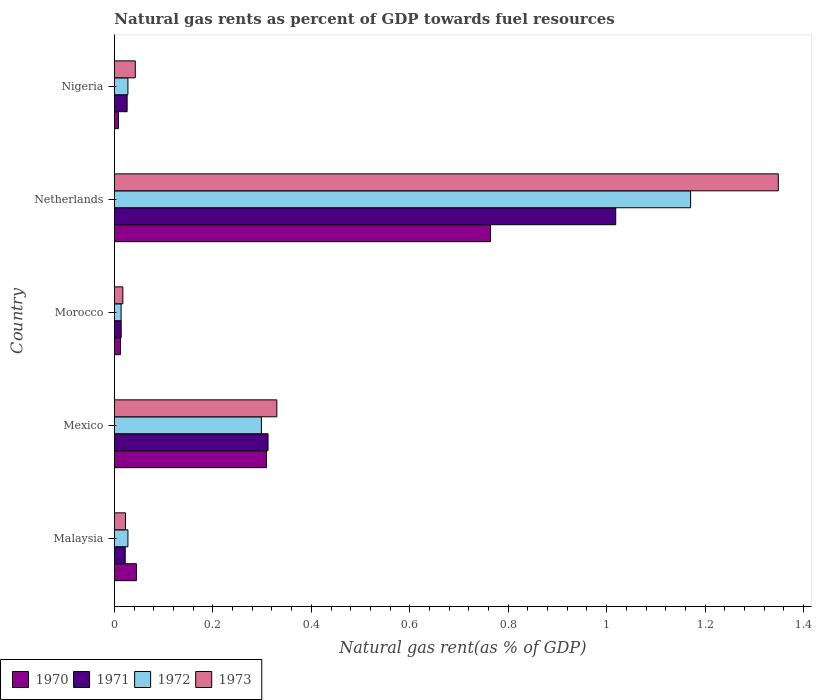How many groups of bars are there?
Your answer should be compact. 5. Are the number of bars per tick equal to the number of legend labels?
Your response must be concise. Yes. How many bars are there on the 4th tick from the top?
Your response must be concise. 4. In how many cases, is the number of bars for a given country not equal to the number of legend labels?
Ensure brevity in your answer.  0. What is the natural gas rent in 1971 in Morocco?
Ensure brevity in your answer.  0.01. Across all countries, what is the maximum natural gas rent in 1972?
Keep it short and to the point. 1.17. Across all countries, what is the minimum natural gas rent in 1973?
Your answer should be very brief. 0.02. In which country was the natural gas rent in 1970 maximum?
Provide a succinct answer. Netherlands. In which country was the natural gas rent in 1973 minimum?
Make the answer very short. Morocco. What is the total natural gas rent in 1971 in the graph?
Keep it short and to the point. 1.39. What is the difference between the natural gas rent in 1973 in Netherlands and that in Nigeria?
Provide a short and direct response. 1.31. What is the difference between the natural gas rent in 1972 in Morocco and the natural gas rent in 1973 in Malaysia?
Provide a short and direct response. -0.01. What is the average natural gas rent in 1970 per country?
Ensure brevity in your answer.  0.23. What is the difference between the natural gas rent in 1972 and natural gas rent in 1970 in Malaysia?
Keep it short and to the point. -0.02. In how many countries, is the natural gas rent in 1970 greater than 0.8400000000000001 %?
Give a very brief answer. 0. What is the ratio of the natural gas rent in 1971 in Malaysia to that in Mexico?
Provide a succinct answer. 0.07. Is the natural gas rent in 1970 in Netherlands less than that in Nigeria?
Your response must be concise. No. Is the difference between the natural gas rent in 1972 in Netherlands and Nigeria greater than the difference between the natural gas rent in 1970 in Netherlands and Nigeria?
Your answer should be compact. Yes. What is the difference between the highest and the second highest natural gas rent in 1971?
Give a very brief answer. 0.71. What is the difference between the highest and the lowest natural gas rent in 1972?
Make the answer very short. 1.16. In how many countries, is the natural gas rent in 1973 greater than the average natural gas rent in 1973 taken over all countries?
Your answer should be very brief. 1. Is the sum of the natural gas rent in 1970 in Malaysia and Netherlands greater than the maximum natural gas rent in 1971 across all countries?
Give a very brief answer. No. Is it the case that in every country, the sum of the natural gas rent in 1970 and natural gas rent in 1973 is greater than the sum of natural gas rent in 1972 and natural gas rent in 1971?
Give a very brief answer. No. What does the 4th bar from the bottom in Mexico represents?
Offer a very short reply. 1973. How many bars are there?
Your answer should be compact. 20. Are all the bars in the graph horizontal?
Offer a very short reply. Yes. What is the difference between two consecutive major ticks on the X-axis?
Provide a succinct answer. 0.2. Are the values on the major ticks of X-axis written in scientific E-notation?
Your answer should be compact. No. Does the graph contain grids?
Keep it short and to the point. No. Where does the legend appear in the graph?
Provide a short and direct response. Bottom left. How many legend labels are there?
Your answer should be very brief. 4. How are the legend labels stacked?
Provide a short and direct response. Horizontal. What is the title of the graph?
Give a very brief answer. Natural gas rents as percent of GDP towards fuel resources. What is the label or title of the X-axis?
Offer a terse response. Natural gas rent(as % of GDP). What is the label or title of the Y-axis?
Your response must be concise. Country. What is the Natural gas rent(as % of GDP) of 1970 in Malaysia?
Provide a short and direct response. 0.04. What is the Natural gas rent(as % of GDP) in 1971 in Malaysia?
Your response must be concise. 0.02. What is the Natural gas rent(as % of GDP) in 1972 in Malaysia?
Provide a succinct answer. 0.03. What is the Natural gas rent(as % of GDP) in 1973 in Malaysia?
Your answer should be compact. 0.02. What is the Natural gas rent(as % of GDP) of 1970 in Mexico?
Offer a terse response. 0.31. What is the Natural gas rent(as % of GDP) in 1971 in Mexico?
Make the answer very short. 0.31. What is the Natural gas rent(as % of GDP) of 1972 in Mexico?
Offer a terse response. 0.3. What is the Natural gas rent(as % of GDP) of 1973 in Mexico?
Ensure brevity in your answer.  0.33. What is the Natural gas rent(as % of GDP) of 1970 in Morocco?
Give a very brief answer. 0.01. What is the Natural gas rent(as % of GDP) of 1971 in Morocco?
Your answer should be very brief. 0.01. What is the Natural gas rent(as % of GDP) of 1972 in Morocco?
Your answer should be very brief. 0.01. What is the Natural gas rent(as % of GDP) of 1973 in Morocco?
Make the answer very short. 0.02. What is the Natural gas rent(as % of GDP) in 1970 in Netherlands?
Make the answer very short. 0.76. What is the Natural gas rent(as % of GDP) of 1971 in Netherlands?
Give a very brief answer. 1.02. What is the Natural gas rent(as % of GDP) of 1972 in Netherlands?
Keep it short and to the point. 1.17. What is the Natural gas rent(as % of GDP) of 1973 in Netherlands?
Provide a succinct answer. 1.35. What is the Natural gas rent(as % of GDP) of 1970 in Nigeria?
Offer a terse response. 0.01. What is the Natural gas rent(as % of GDP) of 1971 in Nigeria?
Provide a succinct answer. 0.03. What is the Natural gas rent(as % of GDP) in 1972 in Nigeria?
Your response must be concise. 0.03. What is the Natural gas rent(as % of GDP) in 1973 in Nigeria?
Your answer should be compact. 0.04. Across all countries, what is the maximum Natural gas rent(as % of GDP) of 1970?
Keep it short and to the point. 0.76. Across all countries, what is the maximum Natural gas rent(as % of GDP) in 1971?
Make the answer very short. 1.02. Across all countries, what is the maximum Natural gas rent(as % of GDP) of 1972?
Keep it short and to the point. 1.17. Across all countries, what is the maximum Natural gas rent(as % of GDP) in 1973?
Provide a succinct answer. 1.35. Across all countries, what is the minimum Natural gas rent(as % of GDP) in 1970?
Your answer should be very brief. 0.01. Across all countries, what is the minimum Natural gas rent(as % of GDP) in 1971?
Your answer should be compact. 0.01. Across all countries, what is the minimum Natural gas rent(as % of GDP) in 1972?
Your answer should be compact. 0.01. Across all countries, what is the minimum Natural gas rent(as % of GDP) of 1973?
Your response must be concise. 0.02. What is the total Natural gas rent(as % of GDP) in 1970 in the graph?
Ensure brevity in your answer.  1.14. What is the total Natural gas rent(as % of GDP) in 1971 in the graph?
Your answer should be compact. 1.39. What is the total Natural gas rent(as % of GDP) of 1972 in the graph?
Keep it short and to the point. 1.54. What is the total Natural gas rent(as % of GDP) of 1973 in the graph?
Offer a terse response. 1.76. What is the difference between the Natural gas rent(as % of GDP) in 1970 in Malaysia and that in Mexico?
Offer a very short reply. -0.26. What is the difference between the Natural gas rent(as % of GDP) of 1971 in Malaysia and that in Mexico?
Offer a terse response. -0.29. What is the difference between the Natural gas rent(as % of GDP) of 1972 in Malaysia and that in Mexico?
Keep it short and to the point. -0.27. What is the difference between the Natural gas rent(as % of GDP) in 1973 in Malaysia and that in Mexico?
Provide a short and direct response. -0.31. What is the difference between the Natural gas rent(as % of GDP) in 1970 in Malaysia and that in Morocco?
Ensure brevity in your answer.  0.03. What is the difference between the Natural gas rent(as % of GDP) in 1971 in Malaysia and that in Morocco?
Provide a short and direct response. 0.01. What is the difference between the Natural gas rent(as % of GDP) in 1972 in Malaysia and that in Morocco?
Give a very brief answer. 0.01. What is the difference between the Natural gas rent(as % of GDP) of 1973 in Malaysia and that in Morocco?
Offer a very short reply. 0.01. What is the difference between the Natural gas rent(as % of GDP) of 1970 in Malaysia and that in Netherlands?
Your answer should be very brief. -0.72. What is the difference between the Natural gas rent(as % of GDP) in 1971 in Malaysia and that in Netherlands?
Make the answer very short. -1. What is the difference between the Natural gas rent(as % of GDP) in 1972 in Malaysia and that in Netherlands?
Your response must be concise. -1.14. What is the difference between the Natural gas rent(as % of GDP) of 1973 in Malaysia and that in Netherlands?
Your answer should be compact. -1.33. What is the difference between the Natural gas rent(as % of GDP) of 1970 in Malaysia and that in Nigeria?
Keep it short and to the point. 0.04. What is the difference between the Natural gas rent(as % of GDP) in 1971 in Malaysia and that in Nigeria?
Keep it short and to the point. -0. What is the difference between the Natural gas rent(as % of GDP) in 1972 in Malaysia and that in Nigeria?
Your response must be concise. 0. What is the difference between the Natural gas rent(as % of GDP) of 1973 in Malaysia and that in Nigeria?
Your answer should be very brief. -0.02. What is the difference between the Natural gas rent(as % of GDP) in 1970 in Mexico and that in Morocco?
Your response must be concise. 0.3. What is the difference between the Natural gas rent(as % of GDP) of 1971 in Mexico and that in Morocco?
Keep it short and to the point. 0.3. What is the difference between the Natural gas rent(as % of GDP) of 1972 in Mexico and that in Morocco?
Offer a terse response. 0.28. What is the difference between the Natural gas rent(as % of GDP) of 1973 in Mexico and that in Morocco?
Offer a very short reply. 0.31. What is the difference between the Natural gas rent(as % of GDP) in 1970 in Mexico and that in Netherlands?
Provide a succinct answer. -0.46. What is the difference between the Natural gas rent(as % of GDP) of 1971 in Mexico and that in Netherlands?
Ensure brevity in your answer.  -0.71. What is the difference between the Natural gas rent(as % of GDP) of 1972 in Mexico and that in Netherlands?
Make the answer very short. -0.87. What is the difference between the Natural gas rent(as % of GDP) of 1973 in Mexico and that in Netherlands?
Offer a very short reply. -1.02. What is the difference between the Natural gas rent(as % of GDP) of 1970 in Mexico and that in Nigeria?
Keep it short and to the point. 0.3. What is the difference between the Natural gas rent(as % of GDP) of 1971 in Mexico and that in Nigeria?
Offer a terse response. 0.29. What is the difference between the Natural gas rent(as % of GDP) of 1972 in Mexico and that in Nigeria?
Offer a very short reply. 0.27. What is the difference between the Natural gas rent(as % of GDP) in 1973 in Mexico and that in Nigeria?
Your answer should be compact. 0.29. What is the difference between the Natural gas rent(as % of GDP) in 1970 in Morocco and that in Netherlands?
Give a very brief answer. -0.75. What is the difference between the Natural gas rent(as % of GDP) in 1971 in Morocco and that in Netherlands?
Offer a terse response. -1. What is the difference between the Natural gas rent(as % of GDP) of 1972 in Morocco and that in Netherlands?
Your response must be concise. -1.16. What is the difference between the Natural gas rent(as % of GDP) of 1973 in Morocco and that in Netherlands?
Give a very brief answer. -1.33. What is the difference between the Natural gas rent(as % of GDP) of 1970 in Morocco and that in Nigeria?
Keep it short and to the point. 0. What is the difference between the Natural gas rent(as % of GDP) of 1971 in Morocco and that in Nigeria?
Your answer should be very brief. -0.01. What is the difference between the Natural gas rent(as % of GDP) of 1972 in Morocco and that in Nigeria?
Keep it short and to the point. -0.01. What is the difference between the Natural gas rent(as % of GDP) in 1973 in Morocco and that in Nigeria?
Your response must be concise. -0.03. What is the difference between the Natural gas rent(as % of GDP) of 1970 in Netherlands and that in Nigeria?
Your answer should be very brief. 0.76. What is the difference between the Natural gas rent(as % of GDP) in 1972 in Netherlands and that in Nigeria?
Your answer should be very brief. 1.14. What is the difference between the Natural gas rent(as % of GDP) in 1973 in Netherlands and that in Nigeria?
Your answer should be very brief. 1.31. What is the difference between the Natural gas rent(as % of GDP) of 1970 in Malaysia and the Natural gas rent(as % of GDP) of 1971 in Mexico?
Provide a short and direct response. -0.27. What is the difference between the Natural gas rent(as % of GDP) in 1970 in Malaysia and the Natural gas rent(as % of GDP) in 1972 in Mexico?
Make the answer very short. -0.25. What is the difference between the Natural gas rent(as % of GDP) of 1970 in Malaysia and the Natural gas rent(as % of GDP) of 1973 in Mexico?
Provide a succinct answer. -0.29. What is the difference between the Natural gas rent(as % of GDP) in 1971 in Malaysia and the Natural gas rent(as % of GDP) in 1972 in Mexico?
Keep it short and to the point. -0.28. What is the difference between the Natural gas rent(as % of GDP) of 1971 in Malaysia and the Natural gas rent(as % of GDP) of 1973 in Mexico?
Provide a succinct answer. -0.31. What is the difference between the Natural gas rent(as % of GDP) in 1972 in Malaysia and the Natural gas rent(as % of GDP) in 1973 in Mexico?
Your answer should be compact. -0.3. What is the difference between the Natural gas rent(as % of GDP) in 1970 in Malaysia and the Natural gas rent(as % of GDP) in 1971 in Morocco?
Your response must be concise. 0.03. What is the difference between the Natural gas rent(as % of GDP) in 1970 in Malaysia and the Natural gas rent(as % of GDP) in 1972 in Morocco?
Your answer should be compact. 0.03. What is the difference between the Natural gas rent(as % of GDP) in 1970 in Malaysia and the Natural gas rent(as % of GDP) in 1973 in Morocco?
Offer a terse response. 0.03. What is the difference between the Natural gas rent(as % of GDP) of 1971 in Malaysia and the Natural gas rent(as % of GDP) of 1972 in Morocco?
Your response must be concise. 0.01. What is the difference between the Natural gas rent(as % of GDP) of 1971 in Malaysia and the Natural gas rent(as % of GDP) of 1973 in Morocco?
Provide a succinct answer. 0. What is the difference between the Natural gas rent(as % of GDP) of 1972 in Malaysia and the Natural gas rent(as % of GDP) of 1973 in Morocco?
Give a very brief answer. 0.01. What is the difference between the Natural gas rent(as % of GDP) of 1970 in Malaysia and the Natural gas rent(as % of GDP) of 1971 in Netherlands?
Offer a terse response. -0.97. What is the difference between the Natural gas rent(as % of GDP) of 1970 in Malaysia and the Natural gas rent(as % of GDP) of 1972 in Netherlands?
Offer a terse response. -1.13. What is the difference between the Natural gas rent(as % of GDP) of 1970 in Malaysia and the Natural gas rent(as % of GDP) of 1973 in Netherlands?
Ensure brevity in your answer.  -1.3. What is the difference between the Natural gas rent(as % of GDP) of 1971 in Malaysia and the Natural gas rent(as % of GDP) of 1972 in Netherlands?
Ensure brevity in your answer.  -1.15. What is the difference between the Natural gas rent(as % of GDP) in 1971 in Malaysia and the Natural gas rent(as % of GDP) in 1973 in Netherlands?
Your answer should be very brief. -1.33. What is the difference between the Natural gas rent(as % of GDP) in 1972 in Malaysia and the Natural gas rent(as % of GDP) in 1973 in Netherlands?
Ensure brevity in your answer.  -1.32. What is the difference between the Natural gas rent(as % of GDP) of 1970 in Malaysia and the Natural gas rent(as % of GDP) of 1971 in Nigeria?
Keep it short and to the point. 0.02. What is the difference between the Natural gas rent(as % of GDP) of 1970 in Malaysia and the Natural gas rent(as % of GDP) of 1972 in Nigeria?
Your answer should be very brief. 0.02. What is the difference between the Natural gas rent(as % of GDP) of 1970 in Malaysia and the Natural gas rent(as % of GDP) of 1973 in Nigeria?
Give a very brief answer. 0. What is the difference between the Natural gas rent(as % of GDP) in 1971 in Malaysia and the Natural gas rent(as % of GDP) in 1972 in Nigeria?
Keep it short and to the point. -0.01. What is the difference between the Natural gas rent(as % of GDP) in 1971 in Malaysia and the Natural gas rent(as % of GDP) in 1973 in Nigeria?
Your answer should be compact. -0.02. What is the difference between the Natural gas rent(as % of GDP) in 1972 in Malaysia and the Natural gas rent(as % of GDP) in 1973 in Nigeria?
Your response must be concise. -0.01. What is the difference between the Natural gas rent(as % of GDP) in 1970 in Mexico and the Natural gas rent(as % of GDP) in 1971 in Morocco?
Provide a succinct answer. 0.3. What is the difference between the Natural gas rent(as % of GDP) of 1970 in Mexico and the Natural gas rent(as % of GDP) of 1972 in Morocco?
Provide a short and direct response. 0.3. What is the difference between the Natural gas rent(as % of GDP) of 1970 in Mexico and the Natural gas rent(as % of GDP) of 1973 in Morocco?
Keep it short and to the point. 0.29. What is the difference between the Natural gas rent(as % of GDP) of 1971 in Mexico and the Natural gas rent(as % of GDP) of 1972 in Morocco?
Make the answer very short. 0.3. What is the difference between the Natural gas rent(as % of GDP) in 1971 in Mexico and the Natural gas rent(as % of GDP) in 1973 in Morocco?
Provide a succinct answer. 0.29. What is the difference between the Natural gas rent(as % of GDP) of 1972 in Mexico and the Natural gas rent(as % of GDP) of 1973 in Morocco?
Make the answer very short. 0.28. What is the difference between the Natural gas rent(as % of GDP) in 1970 in Mexico and the Natural gas rent(as % of GDP) in 1971 in Netherlands?
Your answer should be very brief. -0.71. What is the difference between the Natural gas rent(as % of GDP) of 1970 in Mexico and the Natural gas rent(as % of GDP) of 1972 in Netherlands?
Make the answer very short. -0.86. What is the difference between the Natural gas rent(as % of GDP) of 1970 in Mexico and the Natural gas rent(as % of GDP) of 1973 in Netherlands?
Make the answer very short. -1.04. What is the difference between the Natural gas rent(as % of GDP) of 1971 in Mexico and the Natural gas rent(as % of GDP) of 1972 in Netherlands?
Ensure brevity in your answer.  -0.86. What is the difference between the Natural gas rent(as % of GDP) of 1971 in Mexico and the Natural gas rent(as % of GDP) of 1973 in Netherlands?
Your answer should be compact. -1.04. What is the difference between the Natural gas rent(as % of GDP) of 1972 in Mexico and the Natural gas rent(as % of GDP) of 1973 in Netherlands?
Your answer should be very brief. -1.05. What is the difference between the Natural gas rent(as % of GDP) of 1970 in Mexico and the Natural gas rent(as % of GDP) of 1971 in Nigeria?
Your answer should be very brief. 0.28. What is the difference between the Natural gas rent(as % of GDP) of 1970 in Mexico and the Natural gas rent(as % of GDP) of 1972 in Nigeria?
Offer a very short reply. 0.28. What is the difference between the Natural gas rent(as % of GDP) in 1970 in Mexico and the Natural gas rent(as % of GDP) in 1973 in Nigeria?
Your answer should be very brief. 0.27. What is the difference between the Natural gas rent(as % of GDP) in 1971 in Mexico and the Natural gas rent(as % of GDP) in 1972 in Nigeria?
Your answer should be compact. 0.28. What is the difference between the Natural gas rent(as % of GDP) in 1971 in Mexico and the Natural gas rent(as % of GDP) in 1973 in Nigeria?
Provide a succinct answer. 0.27. What is the difference between the Natural gas rent(as % of GDP) in 1972 in Mexico and the Natural gas rent(as % of GDP) in 1973 in Nigeria?
Give a very brief answer. 0.26. What is the difference between the Natural gas rent(as % of GDP) of 1970 in Morocco and the Natural gas rent(as % of GDP) of 1971 in Netherlands?
Give a very brief answer. -1.01. What is the difference between the Natural gas rent(as % of GDP) in 1970 in Morocco and the Natural gas rent(as % of GDP) in 1972 in Netherlands?
Provide a short and direct response. -1.16. What is the difference between the Natural gas rent(as % of GDP) in 1970 in Morocco and the Natural gas rent(as % of GDP) in 1973 in Netherlands?
Offer a very short reply. -1.34. What is the difference between the Natural gas rent(as % of GDP) in 1971 in Morocco and the Natural gas rent(as % of GDP) in 1972 in Netherlands?
Keep it short and to the point. -1.16. What is the difference between the Natural gas rent(as % of GDP) of 1971 in Morocco and the Natural gas rent(as % of GDP) of 1973 in Netherlands?
Ensure brevity in your answer.  -1.33. What is the difference between the Natural gas rent(as % of GDP) of 1972 in Morocco and the Natural gas rent(as % of GDP) of 1973 in Netherlands?
Make the answer very short. -1.34. What is the difference between the Natural gas rent(as % of GDP) in 1970 in Morocco and the Natural gas rent(as % of GDP) in 1971 in Nigeria?
Give a very brief answer. -0.01. What is the difference between the Natural gas rent(as % of GDP) of 1970 in Morocco and the Natural gas rent(as % of GDP) of 1972 in Nigeria?
Your answer should be compact. -0.02. What is the difference between the Natural gas rent(as % of GDP) in 1970 in Morocco and the Natural gas rent(as % of GDP) in 1973 in Nigeria?
Provide a short and direct response. -0.03. What is the difference between the Natural gas rent(as % of GDP) in 1971 in Morocco and the Natural gas rent(as % of GDP) in 1972 in Nigeria?
Ensure brevity in your answer.  -0.01. What is the difference between the Natural gas rent(as % of GDP) in 1971 in Morocco and the Natural gas rent(as % of GDP) in 1973 in Nigeria?
Provide a short and direct response. -0.03. What is the difference between the Natural gas rent(as % of GDP) of 1972 in Morocco and the Natural gas rent(as % of GDP) of 1973 in Nigeria?
Offer a terse response. -0.03. What is the difference between the Natural gas rent(as % of GDP) of 1970 in Netherlands and the Natural gas rent(as % of GDP) of 1971 in Nigeria?
Provide a short and direct response. 0.74. What is the difference between the Natural gas rent(as % of GDP) of 1970 in Netherlands and the Natural gas rent(as % of GDP) of 1972 in Nigeria?
Give a very brief answer. 0.74. What is the difference between the Natural gas rent(as % of GDP) of 1970 in Netherlands and the Natural gas rent(as % of GDP) of 1973 in Nigeria?
Provide a short and direct response. 0.72. What is the difference between the Natural gas rent(as % of GDP) of 1971 in Netherlands and the Natural gas rent(as % of GDP) of 1972 in Nigeria?
Your answer should be very brief. 0.99. What is the difference between the Natural gas rent(as % of GDP) in 1972 in Netherlands and the Natural gas rent(as % of GDP) in 1973 in Nigeria?
Keep it short and to the point. 1.13. What is the average Natural gas rent(as % of GDP) in 1970 per country?
Provide a short and direct response. 0.23. What is the average Natural gas rent(as % of GDP) of 1971 per country?
Provide a succinct answer. 0.28. What is the average Natural gas rent(as % of GDP) of 1972 per country?
Your response must be concise. 0.31. What is the average Natural gas rent(as % of GDP) in 1973 per country?
Give a very brief answer. 0.35. What is the difference between the Natural gas rent(as % of GDP) of 1970 and Natural gas rent(as % of GDP) of 1971 in Malaysia?
Offer a terse response. 0.02. What is the difference between the Natural gas rent(as % of GDP) in 1970 and Natural gas rent(as % of GDP) in 1972 in Malaysia?
Your answer should be compact. 0.02. What is the difference between the Natural gas rent(as % of GDP) of 1970 and Natural gas rent(as % of GDP) of 1973 in Malaysia?
Offer a terse response. 0.02. What is the difference between the Natural gas rent(as % of GDP) in 1971 and Natural gas rent(as % of GDP) in 1972 in Malaysia?
Your answer should be very brief. -0.01. What is the difference between the Natural gas rent(as % of GDP) in 1971 and Natural gas rent(as % of GDP) in 1973 in Malaysia?
Make the answer very short. -0. What is the difference between the Natural gas rent(as % of GDP) of 1972 and Natural gas rent(as % of GDP) of 1973 in Malaysia?
Make the answer very short. 0.01. What is the difference between the Natural gas rent(as % of GDP) in 1970 and Natural gas rent(as % of GDP) in 1971 in Mexico?
Offer a terse response. -0. What is the difference between the Natural gas rent(as % of GDP) of 1970 and Natural gas rent(as % of GDP) of 1972 in Mexico?
Make the answer very short. 0.01. What is the difference between the Natural gas rent(as % of GDP) in 1970 and Natural gas rent(as % of GDP) in 1973 in Mexico?
Make the answer very short. -0.02. What is the difference between the Natural gas rent(as % of GDP) of 1971 and Natural gas rent(as % of GDP) of 1972 in Mexico?
Keep it short and to the point. 0.01. What is the difference between the Natural gas rent(as % of GDP) of 1971 and Natural gas rent(as % of GDP) of 1973 in Mexico?
Ensure brevity in your answer.  -0.02. What is the difference between the Natural gas rent(as % of GDP) in 1972 and Natural gas rent(as % of GDP) in 1973 in Mexico?
Ensure brevity in your answer.  -0.03. What is the difference between the Natural gas rent(as % of GDP) in 1970 and Natural gas rent(as % of GDP) in 1971 in Morocco?
Your answer should be compact. -0. What is the difference between the Natural gas rent(as % of GDP) of 1970 and Natural gas rent(as % of GDP) of 1972 in Morocco?
Offer a very short reply. -0. What is the difference between the Natural gas rent(as % of GDP) in 1970 and Natural gas rent(as % of GDP) in 1973 in Morocco?
Your answer should be very brief. -0. What is the difference between the Natural gas rent(as % of GDP) in 1971 and Natural gas rent(as % of GDP) in 1972 in Morocco?
Offer a terse response. 0. What is the difference between the Natural gas rent(as % of GDP) in 1971 and Natural gas rent(as % of GDP) in 1973 in Morocco?
Offer a very short reply. -0. What is the difference between the Natural gas rent(as % of GDP) of 1972 and Natural gas rent(as % of GDP) of 1973 in Morocco?
Make the answer very short. -0. What is the difference between the Natural gas rent(as % of GDP) of 1970 and Natural gas rent(as % of GDP) of 1971 in Netherlands?
Give a very brief answer. -0.25. What is the difference between the Natural gas rent(as % of GDP) in 1970 and Natural gas rent(as % of GDP) in 1972 in Netherlands?
Your response must be concise. -0.41. What is the difference between the Natural gas rent(as % of GDP) of 1970 and Natural gas rent(as % of GDP) of 1973 in Netherlands?
Your response must be concise. -0.58. What is the difference between the Natural gas rent(as % of GDP) of 1971 and Natural gas rent(as % of GDP) of 1972 in Netherlands?
Give a very brief answer. -0.15. What is the difference between the Natural gas rent(as % of GDP) in 1971 and Natural gas rent(as % of GDP) in 1973 in Netherlands?
Ensure brevity in your answer.  -0.33. What is the difference between the Natural gas rent(as % of GDP) of 1972 and Natural gas rent(as % of GDP) of 1973 in Netherlands?
Ensure brevity in your answer.  -0.18. What is the difference between the Natural gas rent(as % of GDP) in 1970 and Natural gas rent(as % of GDP) in 1971 in Nigeria?
Provide a short and direct response. -0.02. What is the difference between the Natural gas rent(as % of GDP) in 1970 and Natural gas rent(as % of GDP) in 1972 in Nigeria?
Give a very brief answer. -0.02. What is the difference between the Natural gas rent(as % of GDP) in 1970 and Natural gas rent(as % of GDP) in 1973 in Nigeria?
Provide a succinct answer. -0.03. What is the difference between the Natural gas rent(as % of GDP) in 1971 and Natural gas rent(as % of GDP) in 1972 in Nigeria?
Make the answer very short. -0. What is the difference between the Natural gas rent(as % of GDP) in 1971 and Natural gas rent(as % of GDP) in 1973 in Nigeria?
Provide a succinct answer. -0.02. What is the difference between the Natural gas rent(as % of GDP) in 1972 and Natural gas rent(as % of GDP) in 1973 in Nigeria?
Offer a terse response. -0.01. What is the ratio of the Natural gas rent(as % of GDP) in 1970 in Malaysia to that in Mexico?
Ensure brevity in your answer.  0.14. What is the ratio of the Natural gas rent(as % of GDP) in 1971 in Malaysia to that in Mexico?
Provide a succinct answer. 0.07. What is the ratio of the Natural gas rent(as % of GDP) in 1972 in Malaysia to that in Mexico?
Offer a terse response. 0.09. What is the ratio of the Natural gas rent(as % of GDP) of 1973 in Malaysia to that in Mexico?
Keep it short and to the point. 0.07. What is the ratio of the Natural gas rent(as % of GDP) of 1970 in Malaysia to that in Morocco?
Provide a short and direct response. 3.62. What is the ratio of the Natural gas rent(as % of GDP) in 1971 in Malaysia to that in Morocco?
Your answer should be very brief. 1.6. What is the ratio of the Natural gas rent(as % of GDP) of 1972 in Malaysia to that in Morocco?
Ensure brevity in your answer.  2.03. What is the ratio of the Natural gas rent(as % of GDP) in 1973 in Malaysia to that in Morocco?
Your answer should be very brief. 1.31. What is the ratio of the Natural gas rent(as % of GDP) in 1970 in Malaysia to that in Netherlands?
Ensure brevity in your answer.  0.06. What is the ratio of the Natural gas rent(as % of GDP) in 1971 in Malaysia to that in Netherlands?
Give a very brief answer. 0.02. What is the ratio of the Natural gas rent(as % of GDP) of 1972 in Malaysia to that in Netherlands?
Provide a succinct answer. 0.02. What is the ratio of the Natural gas rent(as % of GDP) of 1973 in Malaysia to that in Netherlands?
Keep it short and to the point. 0.02. What is the ratio of the Natural gas rent(as % of GDP) of 1970 in Malaysia to that in Nigeria?
Offer a very short reply. 5.5. What is the ratio of the Natural gas rent(as % of GDP) of 1971 in Malaysia to that in Nigeria?
Your response must be concise. 0.85. What is the ratio of the Natural gas rent(as % of GDP) of 1973 in Malaysia to that in Nigeria?
Offer a terse response. 0.53. What is the ratio of the Natural gas rent(as % of GDP) in 1970 in Mexico to that in Morocco?
Give a very brief answer. 25. What is the ratio of the Natural gas rent(as % of GDP) of 1971 in Mexico to that in Morocco?
Give a very brief answer. 22.74. What is the ratio of the Natural gas rent(as % of GDP) of 1972 in Mexico to that in Morocco?
Provide a short and direct response. 22.04. What is the ratio of the Natural gas rent(as % of GDP) in 1973 in Mexico to that in Morocco?
Provide a succinct answer. 19.3. What is the ratio of the Natural gas rent(as % of GDP) of 1970 in Mexico to that in Netherlands?
Your answer should be compact. 0.4. What is the ratio of the Natural gas rent(as % of GDP) in 1971 in Mexico to that in Netherlands?
Give a very brief answer. 0.31. What is the ratio of the Natural gas rent(as % of GDP) of 1972 in Mexico to that in Netherlands?
Your response must be concise. 0.26. What is the ratio of the Natural gas rent(as % of GDP) in 1973 in Mexico to that in Netherlands?
Keep it short and to the point. 0.24. What is the ratio of the Natural gas rent(as % of GDP) in 1970 in Mexico to that in Nigeria?
Your response must be concise. 37.97. What is the ratio of the Natural gas rent(as % of GDP) of 1971 in Mexico to that in Nigeria?
Your answer should be compact. 12.1. What is the ratio of the Natural gas rent(as % of GDP) of 1972 in Mexico to that in Nigeria?
Provide a short and direct response. 10.89. What is the ratio of the Natural gas rent(as % of GDP) of 1973 in Mexico to that in Nigeria?
Your answer should be compact. 7.79. What is the ratio of the Natural gas rent(as % of GDP) in 1970 in Morocco to that in Netherlands?
Offer a very short reply. 0.02. What is the ratio of the Natural gas rent(as % of GDP) of 1971 in Morocco to that in Netherlands?
Offer a very short reply. 0.01. What is the ratio of the Natural gas rent(as % of GDP) of 1972 in Morocco to that in Netherlands?
Provide a succinct answer. 0.01. What is the ratio of the Natural gas rent(as % of GDP) of 1973 in Morocco to that in Netherlands?
Your answer should be very brief. 0.01. What is the ratio of the Natural gas rent(as % of GDP) of 1970 in Morocco to that in Nigeria?
Keep it short and to the point. 1.52. What is the ratio of the Natural gas rent(as % of GDP) in 1971 in Morocco to that in Nigeria?
Provide a short and direct response. 0.53. What is the ratio of the Natural gas rent(as % of GDP) of 1972 in Morocco to that in Nigeria?
Offer a very short reply. 0.49. What is the ratio of the Natural gas rent(as % of GDP) in 1973 in Morocco to that in Nigeria?
Give a very brief answer. 0.4. What is the ratio of the Natural gas rent(as % of GDP) of 1970 in Netherlands to that in Nigeria?
Offer a very short reply. 93.94. What is the ratio of the Natural gas rent(as % of GDP) in 1971 in Netherlands to that in Nigeria?
Your response must be concise. 39.48. What is the ratio of the Natural gas rent(as % of GDP) in 1972 in Netherlands to that in Nigeria?
Your answer should be very brief. 42.7. What is the ratio of the Natural gas rent(as % of GDP) in 1973 in Netherlands to that in Nigeria?
Offer a terse response. 31.84. What is the difference between the highest and the second highest Natural gas rent(as % of GDP) of 1970?
Offer a very short reply. 0.46. What is the difference between the highest and the second highest Natural gas rent(as % of GDP) in 1971?
Give a very brief answer. 0.71. What is the difference between the highest and the second highest Natural gas rent(as % of GDP) in 1972?
Your response must be concise. 0.87. What is the difference between the highest and the second highest Natural gas rent(as % of GDP) in 1973?
Provide a short and direct response. 1.02. What is the difference between the highest and the lowest Natural gas rent(as % of GDP) in 1970?
Give a very brief answer. 0.76. What is the difference between the highest and the lowest Natural gas rent(as % of GDP) of 1972?
Your response must be concise. 1.16. What is the difference between the highest and the lowest Natural gas rent(as % of GDP) of 1973?
Give a very brief answer. 1.33. 